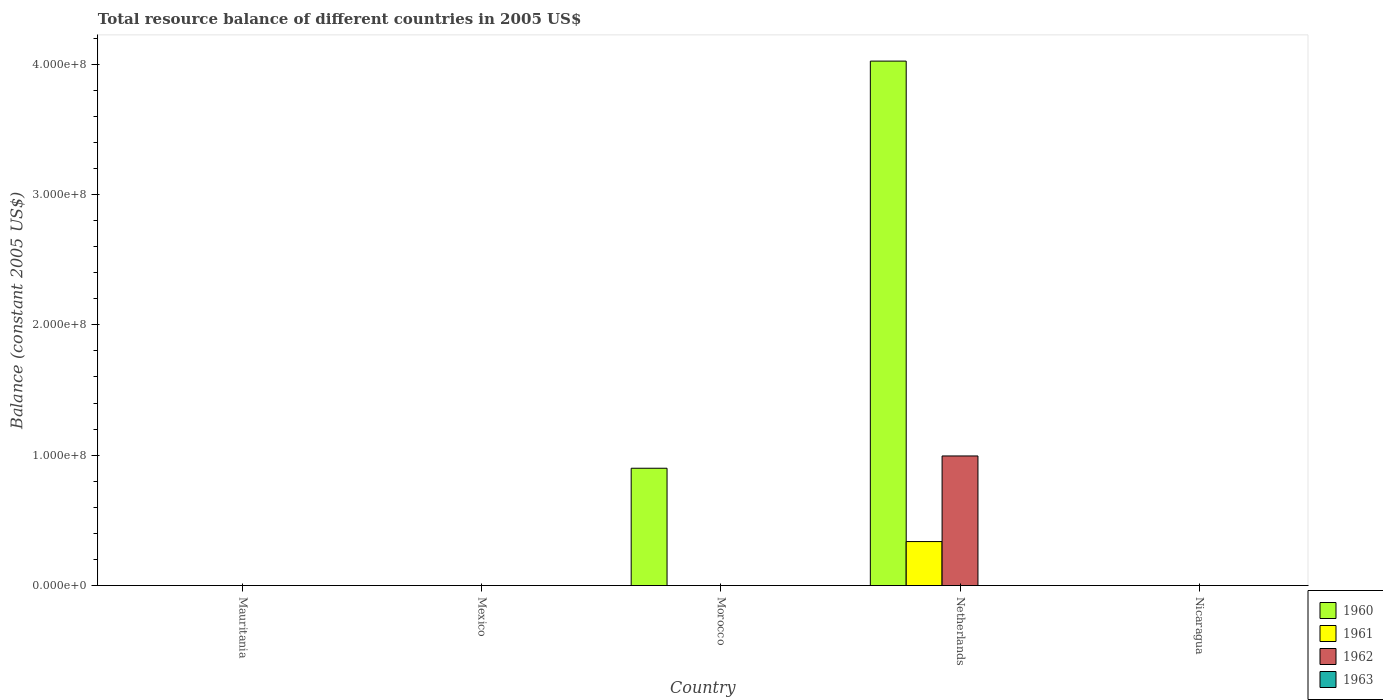How many different coloured bars are there?
Keep it short and to the point. 3. Are the number of bars per tick equal to the number of legend labels?
Keep it short and to the point. No. How many bars are there on the 3rd tick from the left?
Your response must be concise. 1. What is the label of the 1st group of bars from the left?
Provide a succinct answer. Mauritania. What is the total resource balance in 1960 in Mexico?
Provide a short and direct response. 0. Across all countries, what is the maximum total resource balance in 1960?
Provide a short and direct response. 4.02e+08. In which country was the total resource balance in 1961 maximum?
Offer a terse response. Netherlands. What is the total total resource balance in 1962 in the graph?
Keep it short and to the point. 9.94e+07. What is the difference between the total resource balance in 1963 in Nicaragua and the total resource balance in 1961 in Netherlands?
Keep it short and to the point. -3.37e+07. What is the average total resource balance in 1961 per country?
Ensure brevity in your answer.  6.75e+06. What is the difference between the total resource balance of/in 1962 and total resource balance of/in 1960 in Netherlands?
Keep it short and to the point. -3.03e+08. In how many countries, is the total resource balance in 1962 greater than 280000000 US$?
Provide a succinct answer. 0. What is the difference between the highest and the lowest total resource balance in 1961?
Your response must be concise. 3.37e+07. In how many countries, is the total resource balance in 1960 greater than the average total resource balance in 1960 taken over all countries?
Your answer should be compact. 1. Is it the case that in every country, the sum of the total resource balance in 1962 and total resource balance in 1963 is greater than the total resource balance in 1961?
Your answer should be compact. No. Are the values on the major ticks of Y-axis written in scientific E-notation?
Your response must be concise. Yes. Does the graph contain any zero values?
Ensure brevity in your answer.  Yes. How many legend labels are there?
Give a very brief answer. 4. How are the legend labels stacked?
Your answer should be compact. Vertical. What is the title of the graph?
Your response must be concise. Total resource balance of different countries in 2005 US$. Does "2004" appear as one of the legend labels in the graph?
Ensure brevity in your answer.  No. What is the label or title of the X-axis?
Your answer should be compact. Country. What is the label or title of the Y-axis?
Keep it short and to the point. Balance (constant 2005 US$). What is the Balance (constant 2005 US$) of 1960 in Mauritania?
Give a very brief answer. 0. What is the Balance (constant 2005 US$) of 1960 in Mexico?
Give a very brief answer. 0. What is the Balance (constant 2005 US$) of 1961 in Mexico?
Make the answer very short. 0. What is the Balance (constant 2005 US$) of 1962 in Mexico?
Offer a very short reply. 0. What is the Balance (constant 2005 US$) in 1963 in Mexico?
Offer a terse response. 0. What is the Balance (constant 2005 US$) in 1960 in Morocco?
Ensure brevity in your answer.  9.00e+07. What is the Balance (constant 2005 US$) of 1961 in Morocco?
Provide a succinct answer. 0. What is the Balance (constant 2005 US$) in 1963 in Morocco?
Ensure brevity in your answer.  0. What is the Balance (constant 2005 US$) of 1960 in Netherlands?
Offer a terse response. 4.02e+08. What is the Balance (constant 2005 US$) of 1961 in Netherlands?
Your answer should be compact. 3.37e+07. What is the Balance (constant 2005 US$) of 1962 in Netherlands?
Provide a succinct answer. 9.94e+07. What is the Balance (constant 2005 US$) of 1963 in Nicaragua?
Keep it short and to the point. 0. Across all countries, what is the maximum Balance (constant 2005 US$) of 1960?
Offer a very short reply. 4.02e+08. Across all countries, what is the maximum Balance (constant 2005 US$) in 1961?
Keep it short and to the point. 3.37e+07. Across all countries, what is the maximum Balance (constant 2005 US$) in 1962?
Ensure brevity in your answer.  9.94e+07. Across all countries, what is the minimum Balance (constant 2005 US$) in 1960?
Make the answer very short. 0. What is the total Balance (constant 2005 US$) in 1960 in the graph?
Keep it short and to the point. 4.92e+08. What is the total Balance (constant 2005 US$) of 1961 in the graph?
Provide a short and direct response. 3.37e+07. What is the total Balance (constant 2005 US$) of 1962 in the graph?
Provide a short and direct response. 9.94e+07. What is the total Balance (constant 2005 US$) in 1963 in the graph?
Ensure brevity in your answer.  0. What is the difference between the Balance (constant 2005 US$) in 1960 in Morocco and that in Netherlands?
Your response must be concise. -3.12e+08. What is the difference between the Balance (constant 2005 US$) in 1960 in Morocco and the Balance (constant 2005 US$) in 1961 in Netherlands?
Provide a succinct answer. 5.63e+07. What is the difference between the Balance (constant 2005 US$) of 1960 in Morocco and the Balance (constant 2005 US$) of 1962 in Netherlands?
Your answer should be compact. -9.42e+06. What is the average Balance (constant 2005 US$) in 1960 per country?
Give a very brief answer. 9.85e+07. What is the average Balance (constant 2005 US$) of 1961 per country?
Ensure brevity in your answer.  6.75e+06. What is the average Balance (constant 2005 US$) of 1962 per country?
Make the answer very short. 1.99e+07. What is the difference between the Balance (constant 2005 US$) of 1960 and Balance (constant 2005 US$) of 1961 in Netherlands?
Your answer should be compact. 3.69e+08. What is the difference between the Balance (constant 2005 US$) of 1960 and Balance (constant 2005 US$) of 1962 in Netherlands?
Offer a terse response. 3.03e+08. What is the difference between the Balance (constant 2005 US$) of 1961 and Balance (constant 2005 US$) of 1962 in Netherlands?
Your response must be concise. -6.57e+07. What is the ratio of the Balance (constant 2005 US$) of 1960 in Morocco to that in Netherlands?
Offer a very short reply. 0.22. What is the difference between the highest and the lowest Balance (constant 2005 US$) in 1960?
Offer a very short reply. 4.02e+08. What is the difference between the highest and the lowest Balance (constant 2005 US$) in 1961?
Provide a short and direct response. 3.37e+07. What is the difference between the highest and the lowest Balance (constant 2005 US$) of 1962?
Make the answer very short. 9.94e+07. 